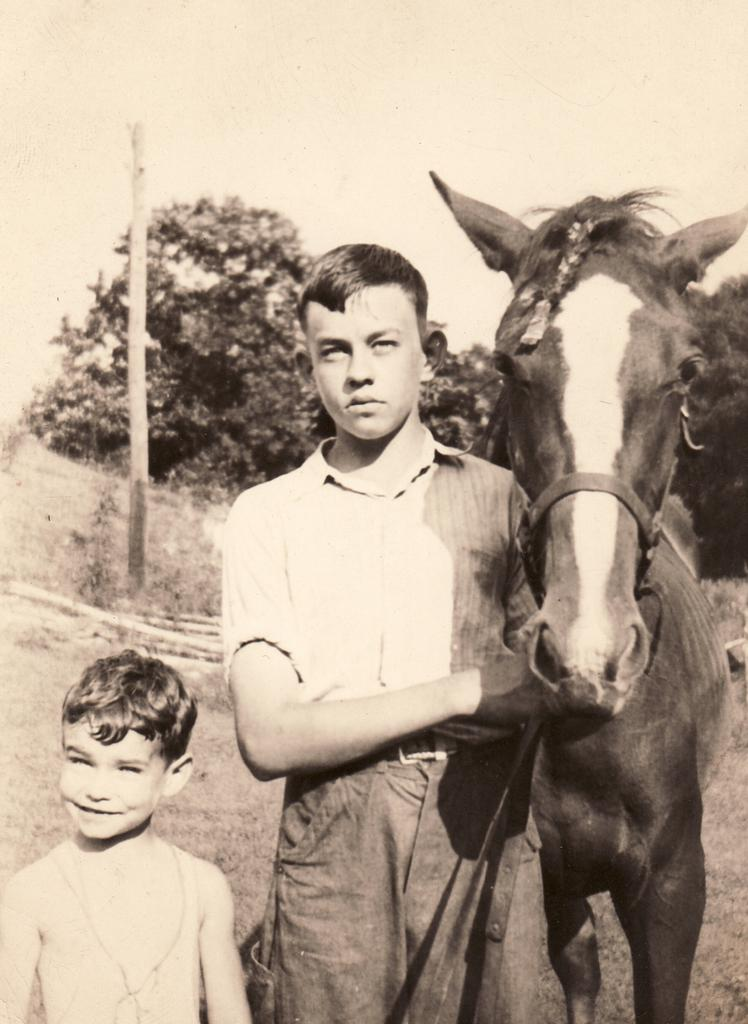How many people are in the image? There are two persons in the image. What are the persons doing in the image? The persons are standing and holding a horse. What can be seen in the background of the image? There are trees and poles in the background of the image. What type of fork is the girl using to eat in the image? There is no girl present in the image, and no fork can be seen. 